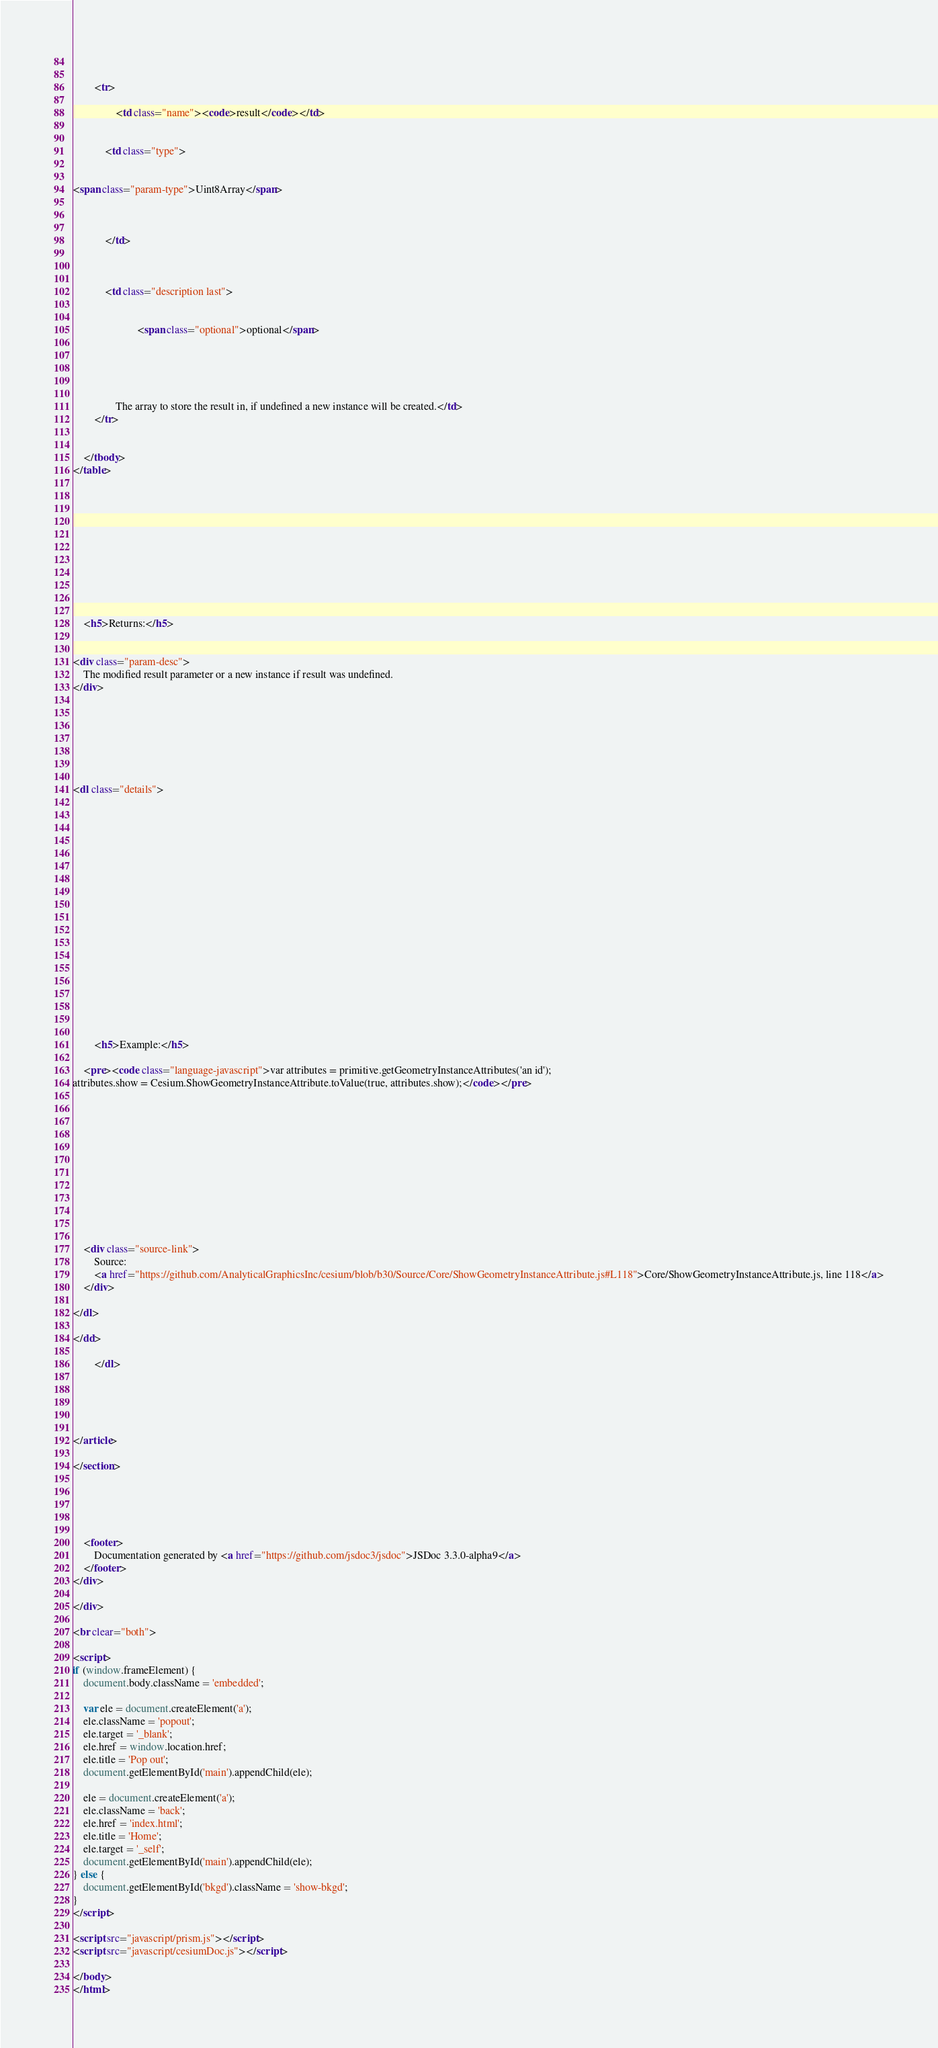Convert code to text. <code><loc_0><loc_0><loc_500><loc_500><_HTML_>
    

        <tr>
            
                <td class="name"><code>result</code></td>
            

            <td class="type">
            
                
<span class="param-type">Uint8Array</span>


            
            </td>

            

            <td class="description last">
            
                
                        <span class="optional">optional</span>
                
                

                
            
                The array to store the result in, if undefined a new instance will be created.</td>
        </tr>

    
    </tbody>
</table>
    

    

    

    

    

    
    <h5>Returns:</h5>
    
            
<div class="param-desc">
    The modified result parameter or a new instance if result was undefined.
</div>


        

    

    
<dl class="details">
    

    

    

    

    

    

    

    

    

    
        <h5>Example:</h5>
        
    <pre><code class="language-javascript">var attributes = primitive.getGeometryInstanceAttributes('an id');
attributes.show = Cesium.ShowGeometryInstanceAttribute.toValue(true, attributes.show);</code></pre>

    

    

    

    

    
    
    
    <div class="source-link">
        Source: 
        <a href="https://github.com/AnalyticalGraphicsInc/cesium/blob/b30/Source/Core/ShowGeometryInstanceAttribute.js#L118">Core/ShowGeometryInstanceAttribute.js, line 118</a>
    </div>
    
</dl>

</dd>

        </dl>
    

    

    
</article>

</section>





    <footer>
        Documentation generated by <a href="https://github.com/jsdoc3/jsdoc">JSDoc 3.3.0-alpha9</a>
    </footer>
</div>

</div>

<br clear="both">

<script>
if (window.frameElement) {
    document.body.className = 'embedded';

    var ele = document.createElement('a');
    ele.className = 'popout';
    ele.target = '_blank';
    ele.href = window.location.href;
    ele.title = 'Pop out';
    document.getElementById('main').appendChild(ele);

    ele = document.createElement('a');
    ele.className = 'back';
    ele.href = 'index.html';
    ele.title = 'Home';
    ele.target = '_self';
    document.getElementById('main').appendChild(ele);
} else {
    document.getElementById('bkgd').className = 'show-bkgd';
}
</script>

<script src="javascript/prism.js"></script>
<script src="javascript/cesiumDoc.js"></script>

</body>
</html></code> 